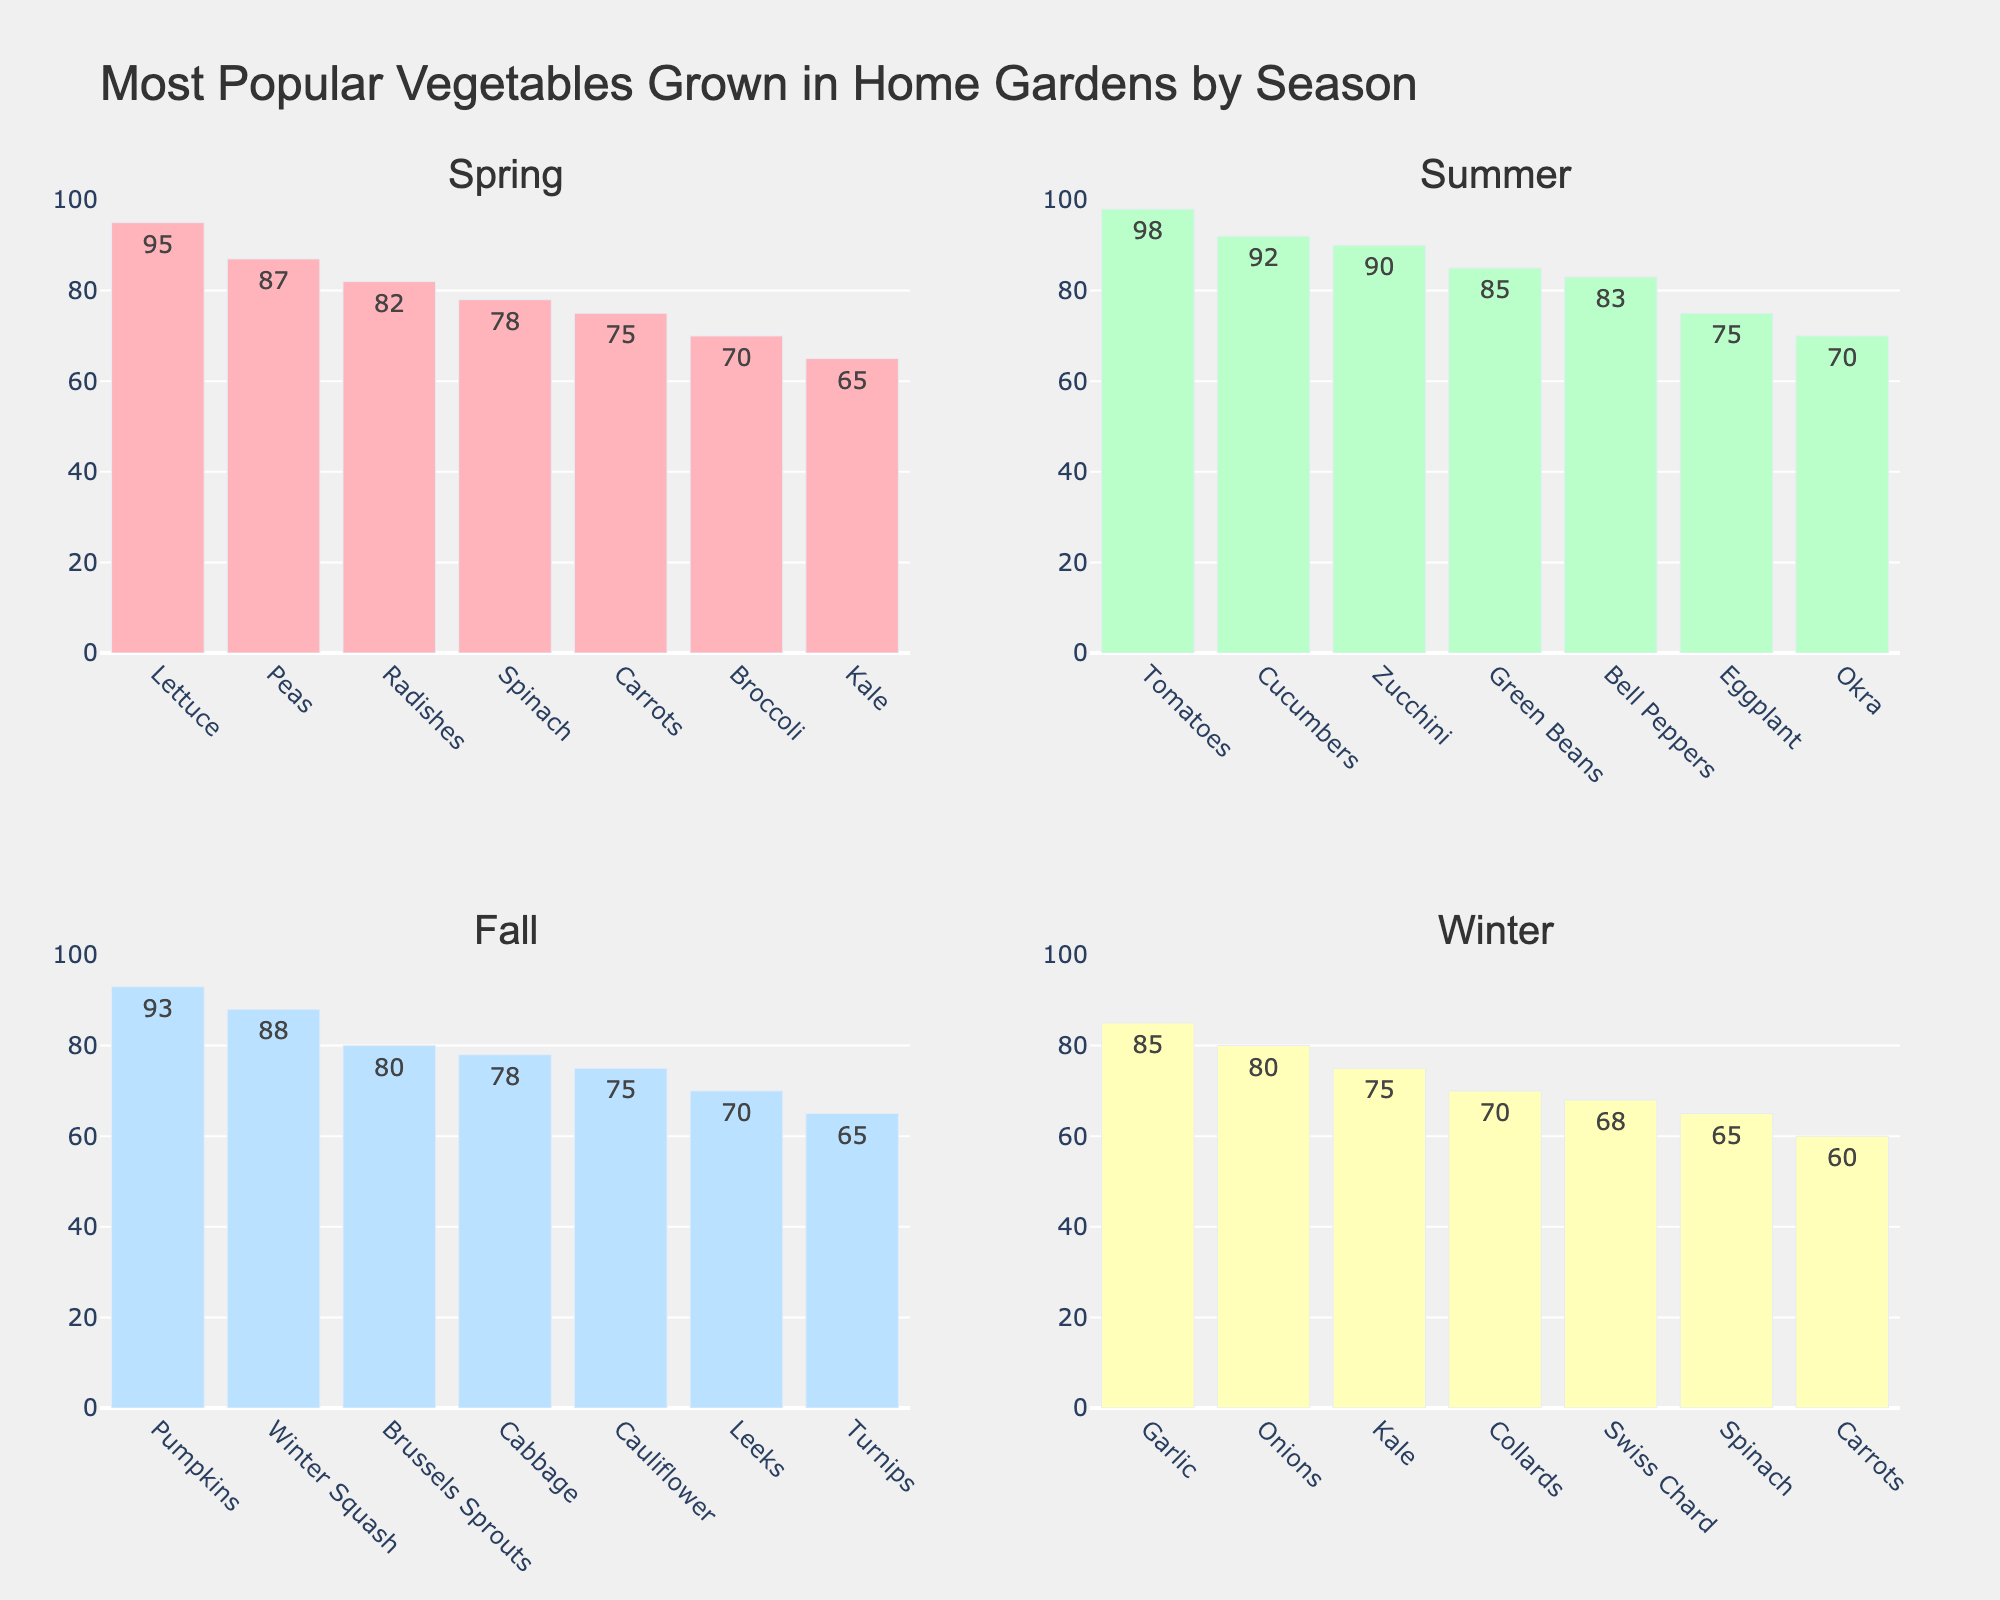Which season has the most popular vegetable, and what is it? The figure must be examined for the highest bar across all seasons. The highest is in the summer subplot for Tomatoes with a value of 98.
Answer: Summer, Tomatoes How much more popular are Tomatoes compared to Eggplant in summer? Locate the bar for Tomatoes (98) and the bar for Eggplant (75) in the summer subplot. Subtract the popularity of Eggplant from Tomatoes (98 - 75).
Answer: 23 Which vegetables are equally popular in winter and what is their popularity? Examine the winter subplot and look for bars with the same height. Both Kale and Spinach have a popularity of 75.
Answer: Kale and Spinach, 75 What is the total popularity score of all vegetables in the spring season? Sum the popularity scores of all vegetables in the spring subplot (Lettuce: 95, Peas: 87, Radishes: 82, Spinach: 78, Carrots: 75, Broccoli: 70, Kale: 65). This totals (95 + 87 + 82 + 78 + 75 + 70 + 65).
Answer: 552 Are Bell Peppers more popular in summer than Brussels Sprouts in fall? Compare the height of the Bell Peppers bar in the summer subplot (83) to the height of the Brussels Sprouts bar in the fall subplot (80). Bell Peppers are more popular.
Answer: Yes What's the difference in popularity between the most popular summer and winter vegetables? Identify the most popular summer vegetable (Tomatoes: 98) and the most popular winter vegetable (Garlic: 85). Subtract the popularity of Garlic from Tomatoes (98 - 85).
Answer: 13 Which season has the highest cumulative popularity score for all vegetables, and what is the score? Sum the popularity scores per season and compare. 
Spring: 552 
Summer: 593 
Fall: 549 
Winter: 503. Summer has the highest score with 593.
Answer: Summer, 593 Is the least popular spring vegetable Kale, and what is its popularity? In the spring subplot, identify the lowest bar which is for Kale with a popularity of 65.
Answer: Yes, 65 